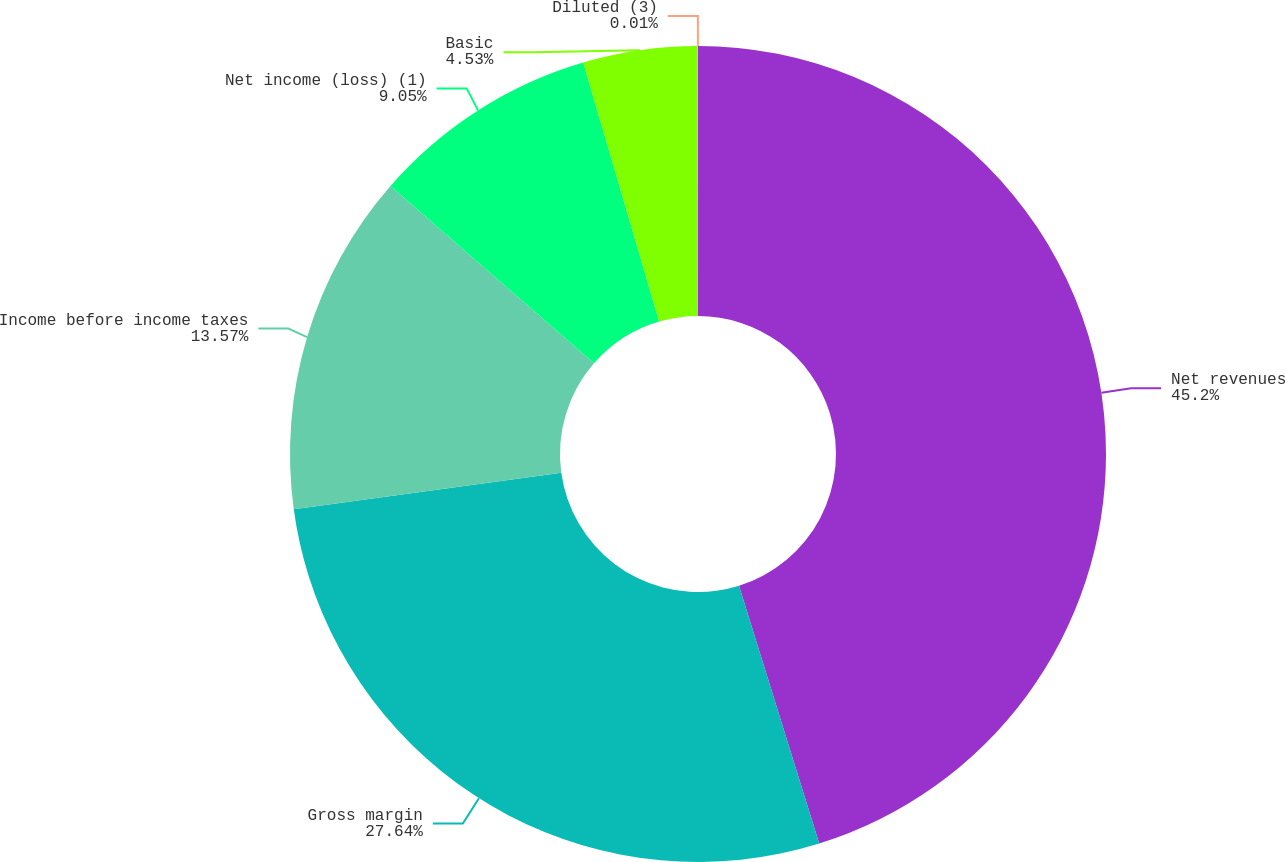Convert chart. <chart><loc_0><loc_0><loc_500><loc_500><pie_chart><fcel>Net revenues<fcel>Gross margin<fcel>Income before income taxes<fcel>Net income (loss) (1)<fcel>Basic<fcel>Diluted (3)<nl><fcel>45.2%<fcel>27.64%<fcel>13.57%<fcel>9.05%<fcel>4.53%<fcel>0.01%<nl></chart> 